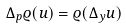Convert formula to latex. <formula><loc_0><loc_0><loc_500><loc_500>\Delta _ { p } \varrho ( u ) = \varrho ( \Delta _ { y } u )</formula> 